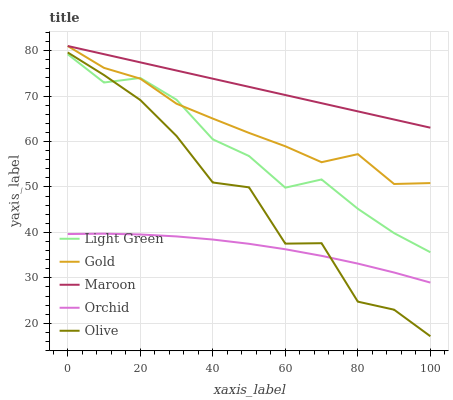Does Orchid have the minimum area under the curve?
Answer yes or no. Yes. Does Maroon have the maximum area under the curve?
Answer yes or no. Yes. Does Gold have the minimum area under the curve?
Answer yes or no. No. Does Gold have the maximum area under the curve?
Answer yes or no. No. Is Maroon the smoothest?
Answer yes or no. Yes. Is Olive the roughest?
Answer yes or no. Yes. Is Gold the smoothest?
Answer yes or no. No. Is Gold the roughest?
Answer yes or no. No. Does Olive have the lowest value?
Answer yes or no. Yes. Does Gold have the lowest value?
Answer yes or no. No. Does Gold have the highest value?
Answer yes or no. Yes. Does Light Green have the highest value?
Answer yes or no. No. Is Light Green less than Maroon?
Answer yes or no. Yes. Is Light Green greater than Orchid?
Answer yes or no. Yes. Does Orchid intersect Olive?
Answer yes or no. Yes. Is Orchid less than Olive?
Answer yes or no. No. Is Orchid greater than Olive?
Answer yes or no. No. Does Light Green intersect Maroon?
Answer yes or no. No. 